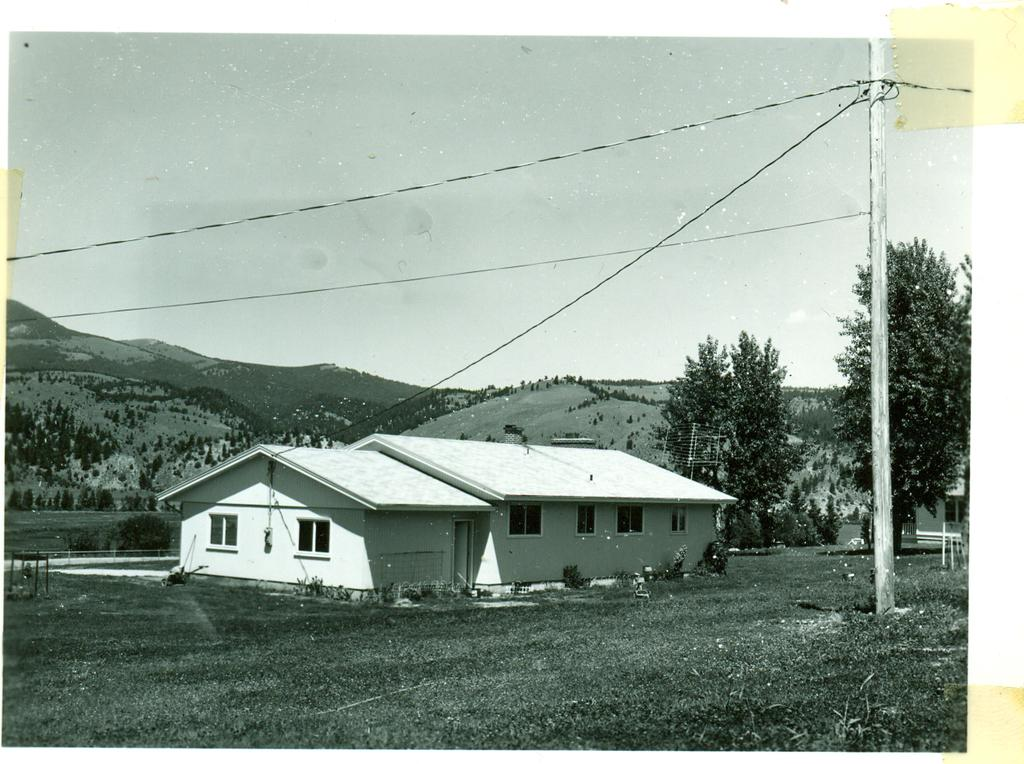What is the main subject in the center of the image? There is a home in the center of the image. What can be seen in the background of the image? There are trees in the background of the image. What is located in the front of the image? There is a pole in the front of the image. What type of ground is visible in the image? There is grass on the ground in the image. How would you describe the sky in the image? The sky is cloudy in the image. What type of bait is being used to catch fish in the image? There is no mention of fish or bait in the image; it features a home, trees, a pole, grass, and a cloudy sky. 